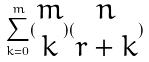<formula> <loc_0><loc_0><loc_500><loc_500>\sum _ { k = 0 } ^ { m } ( \begin{matrix} m \\ k \end{matrix} ) ( \begin{matrix} n \\ r + k \end{matrix} )</formula> 